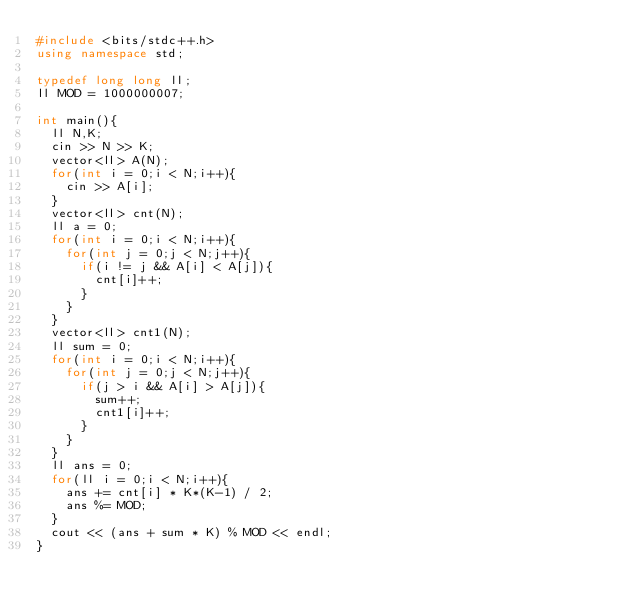<code> <loc_0><loc_0><loc_500><loc_500><_C++_>#include <bits/stdc++.h>
using namespace std;

typedef long long ll;
ll MOD = 1000000007;

int main(){
  ll N,K;
  cin >> N >> K;
  vector<ll> A(N);
  for(int i = 0;i < N;i++){
    cin >> A[i];
  }
  vector<ll> cnt(N);
  ll a = 0;
  for(int i = 0;i < N;i++){
    for(int j = 0;j < N;j++){
      if(i != j && A[i] < A[j]){
        cnt[i]++;
      }
    }
  }
  vector<ll> cnt1(N);
  ll sum = 0;
  for(int i = 0;i < N;i++){
    for(int j = 0;j < N;j++){
      if(j > i && A[i] > A[j]){
        sum++;
        cnt1[i]++;
      }
    }
  }
  ll ans = 0;
  for(ll i = 0;i < N;i++){
    ans += cnt[i] * K*(K-1) / 2;
    ans %= MOD;
  }
  cout << (ans + sum * K) % MOD << endl;
}</code> 